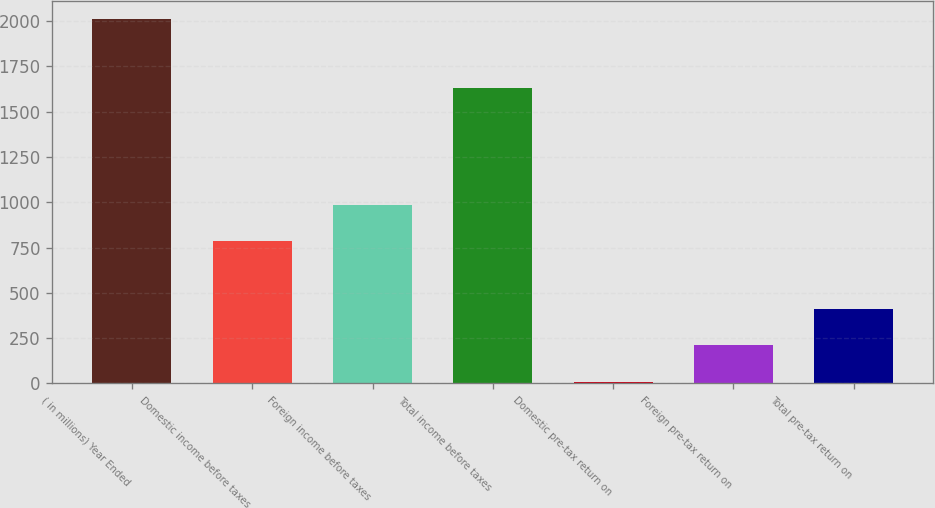Convert chart to OTSL. <chart><loc_0><loc_0><loc_500><loc_500><bar_chart><fcel>( in millions) Year Ended<fcel>Domestic income before taxes<fcel>Foreign income before taxes<fcel>Total income before taxes<fcel>Domestic pre-tax return on<fcel>Foreign pre-tax return on<fcel>Total pre-tax return on<nl><fcel>2012<fcel>786.6<fcel>986.84<fcel>1628.9<fcel>9.6<fcel>209.84<fcel>410.08<nl></chart> 